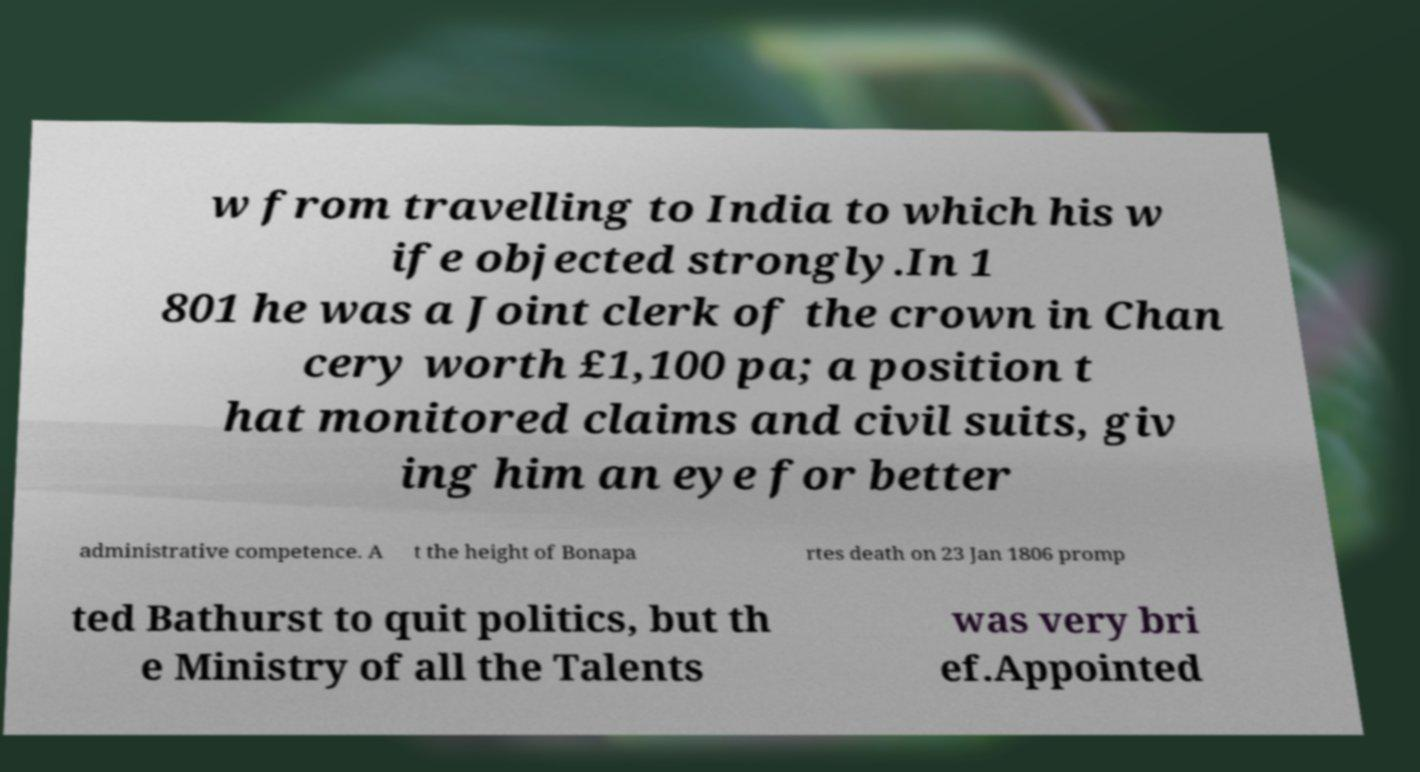Can you accurately transcribe the text from the provided image for me? w from travelling to India to which his w ife objected strongly.In 1 801 he was a Joint clerk of the crown in Chan cery worth £1,100 pa; a position t hat monitored claims and civil suits, giv ing him an eye for better administrative competence. A t the height of Bonapa rtes death on 23 Jan 1806 promp ted Bathurst to quit politics, but th e Ministry of all the Talents was very bri ef.Appointed 